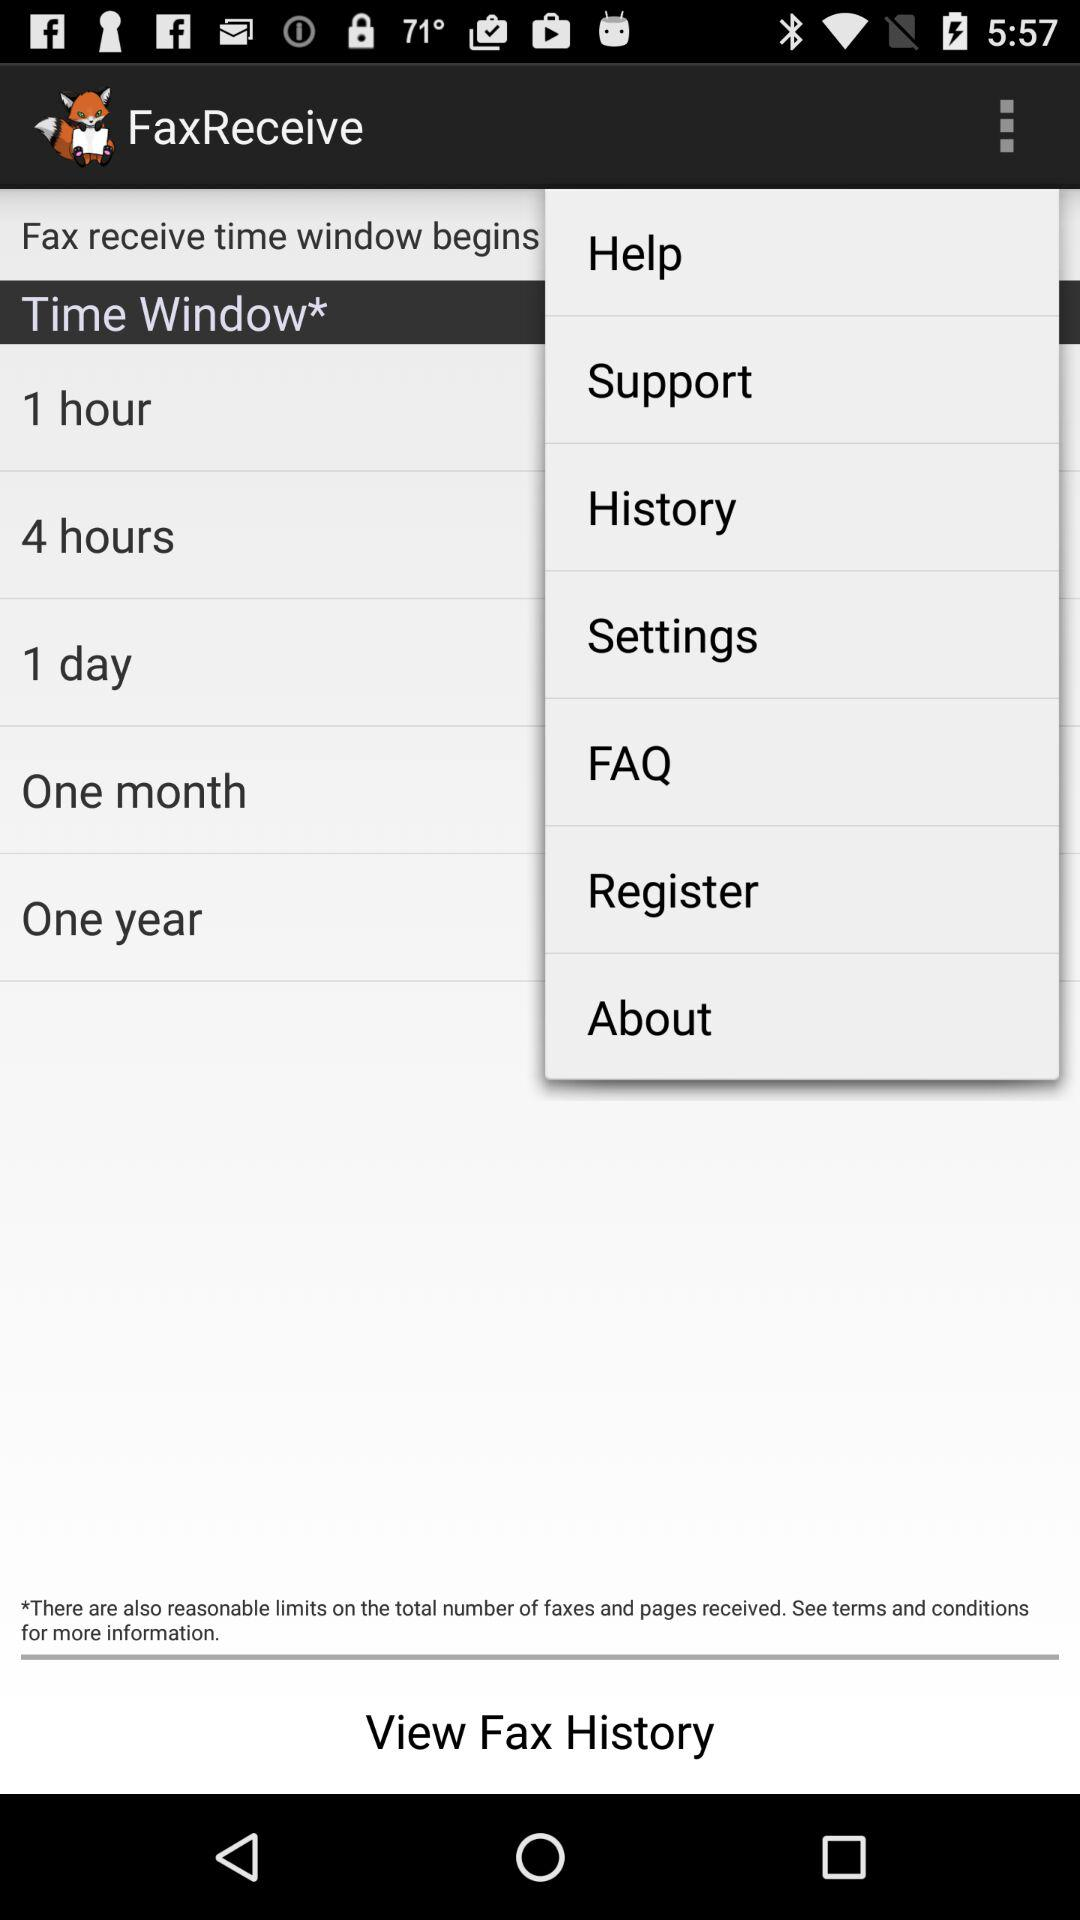How many time windows are available?
Answer the question using a single word or phrase. 5 